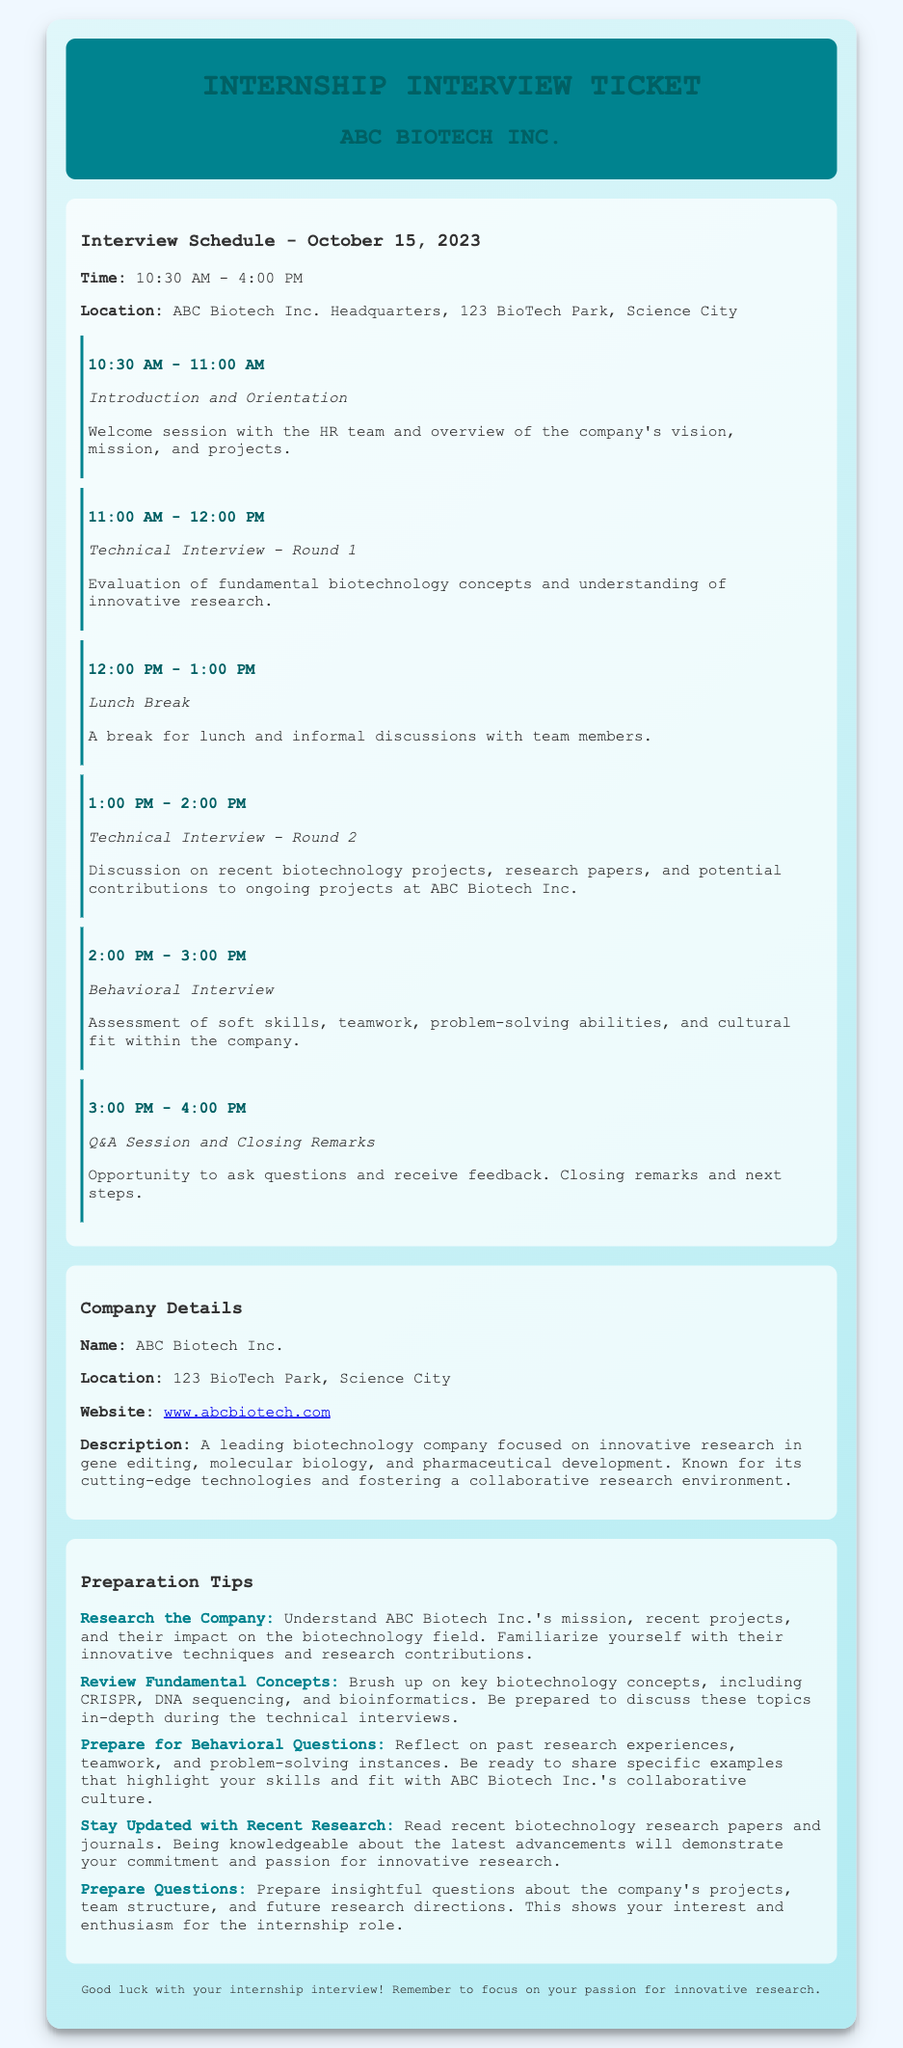What is the date of the interview? The interview is scheduled for October 15, 2023.
Answer: October 15, 2023 What is the location of ABC Biotech Inc.? The document states that the company is located at 123 BioTech Park, Science City.
Answer: 123 BioTech Park, Science City What time does the Technical Interview - Round 1 start? The time for the Technical Interview - Round 1 is from 11:00 AM to 12:00 PM.
Answer: 11:00 AM What type of questions are assessed in the Behavioral Interview? The Behavioral Interview assesses soft skills, teamwork, problem-solving abilities, and cultural fit.
Answer: Soft skills, teamwork, problem-solving, cultural fit What should you prepare for in Technical Interviews? You should brush up on key biotechnology concepts such as CRISPR, DNA sequencing, and bioinformatics.
Answer: Key biotechnology concepts What is the main focus of ABC Biotech Inc.? The company is focused on innovative research in gene editing, molecular biology, and pharmaceutical development.
Answer: Innovative research in gene editing How long is the lunch break during the interview? The lunch break is scheduled for one hour.
Answer: One hour What is one tip for interview preparation? One tip is to stay updated with recent biotechnology research papers and journals.
Answer: Stay updated with research papers 